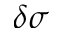Convert formula to latex. <formula><loc_0><loc_0><loc_500><loc_500>\delta \sigma</formula> 